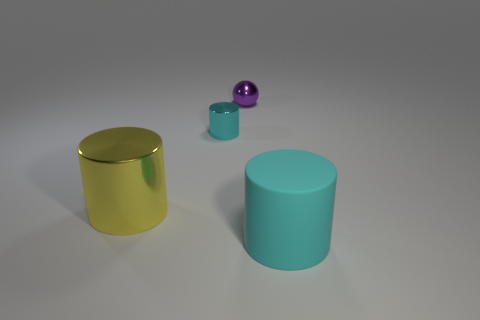Are there more cylinders that are left of the shiny sphere than yellow metallic objects in front of the yellow metallic cylinder?
Make the answer very short. Yes. Is the size of the cyan metallic object the same as the purple metallic ball?
Your answer should be very brief. Yes. There is a big cylinder behind the cyan object that is in front of the tiny metallic cylinder; what is its color?
Offer a very short reply. Yellow. The big shiny cylinder has what color?
Offer a terse response. Yellow. Is there a metallic thing that has the same color as the big rubber cylinder?
Provide a succinct answer. Yes. Is the color of the cylinder that is behind the large yellow thing the same as the rubber object?
Offer a terse response. Yes. What number of objects are cylinders behind the large yellow metallic cylinder or large cyan matte cubes?
Make the answer very short. 1. There is a cyan shiny thing; are there any things behind it?
Your answer should be very brief. Yes. There is a object that is the same color as the small cylinder; what is it made of?
Provide a short and direct response. Rubber. Do the cylinder behind the yellow shiny object and the tiny sphere have the same material?
Offer a terse response. Yes. 